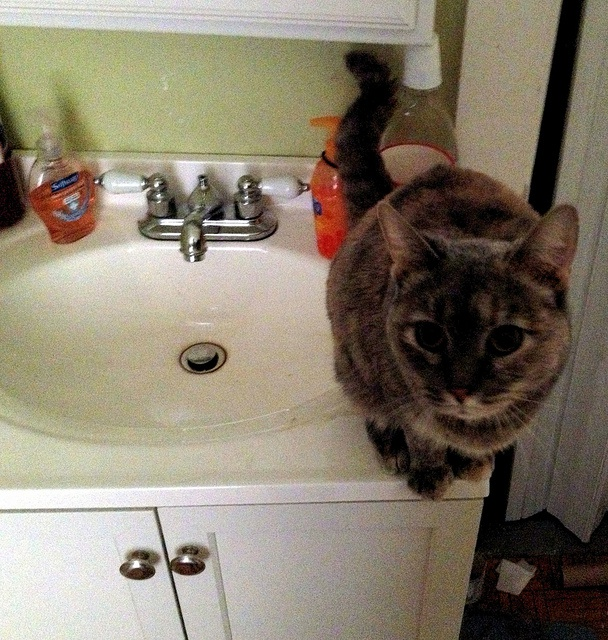Describe the objects in this image and their specific colors. I can see cat in lightgray, black, maroon, and gray tones, sink in lightgray and tan tones, bottle in lightgray, maroon, darkgray, and gray tones, bottle in lightgray, maroon, gray, tan, and brown tones, and bottle in lightgray, brown, and maroon tones in this image. 